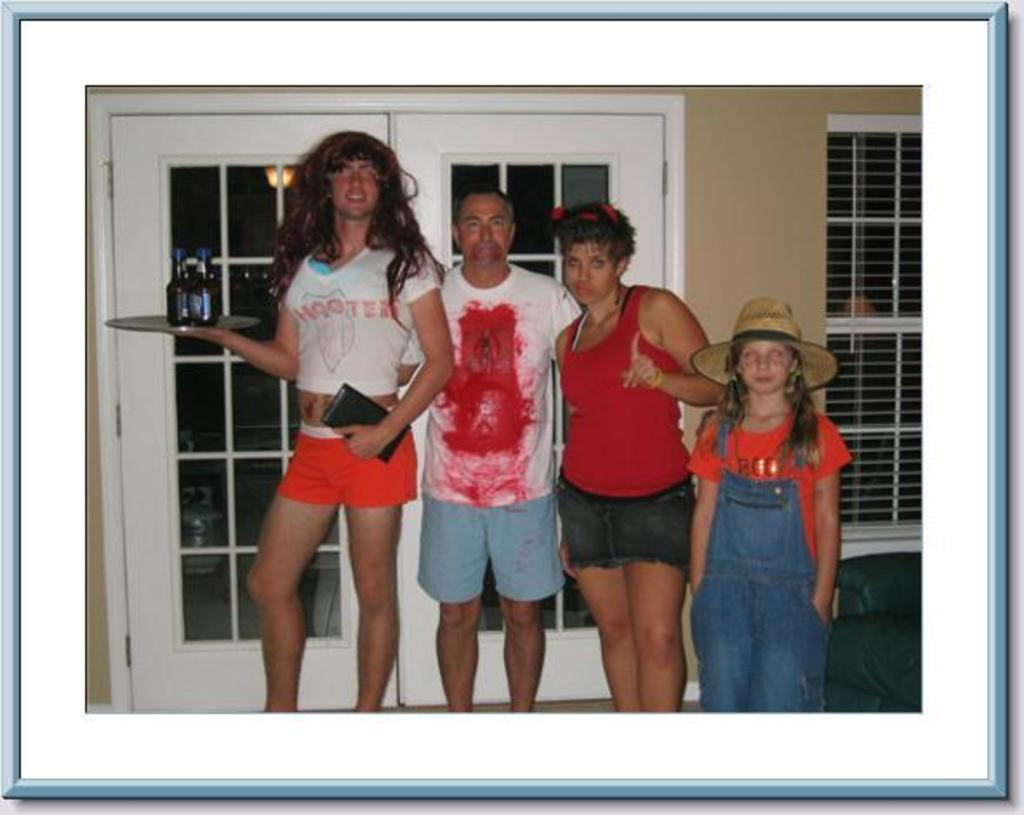<image>
Give a short and clear explanation of the subsequent image. Four people pose for a halloween photo, one wearing a t-shirt saying hooters. 